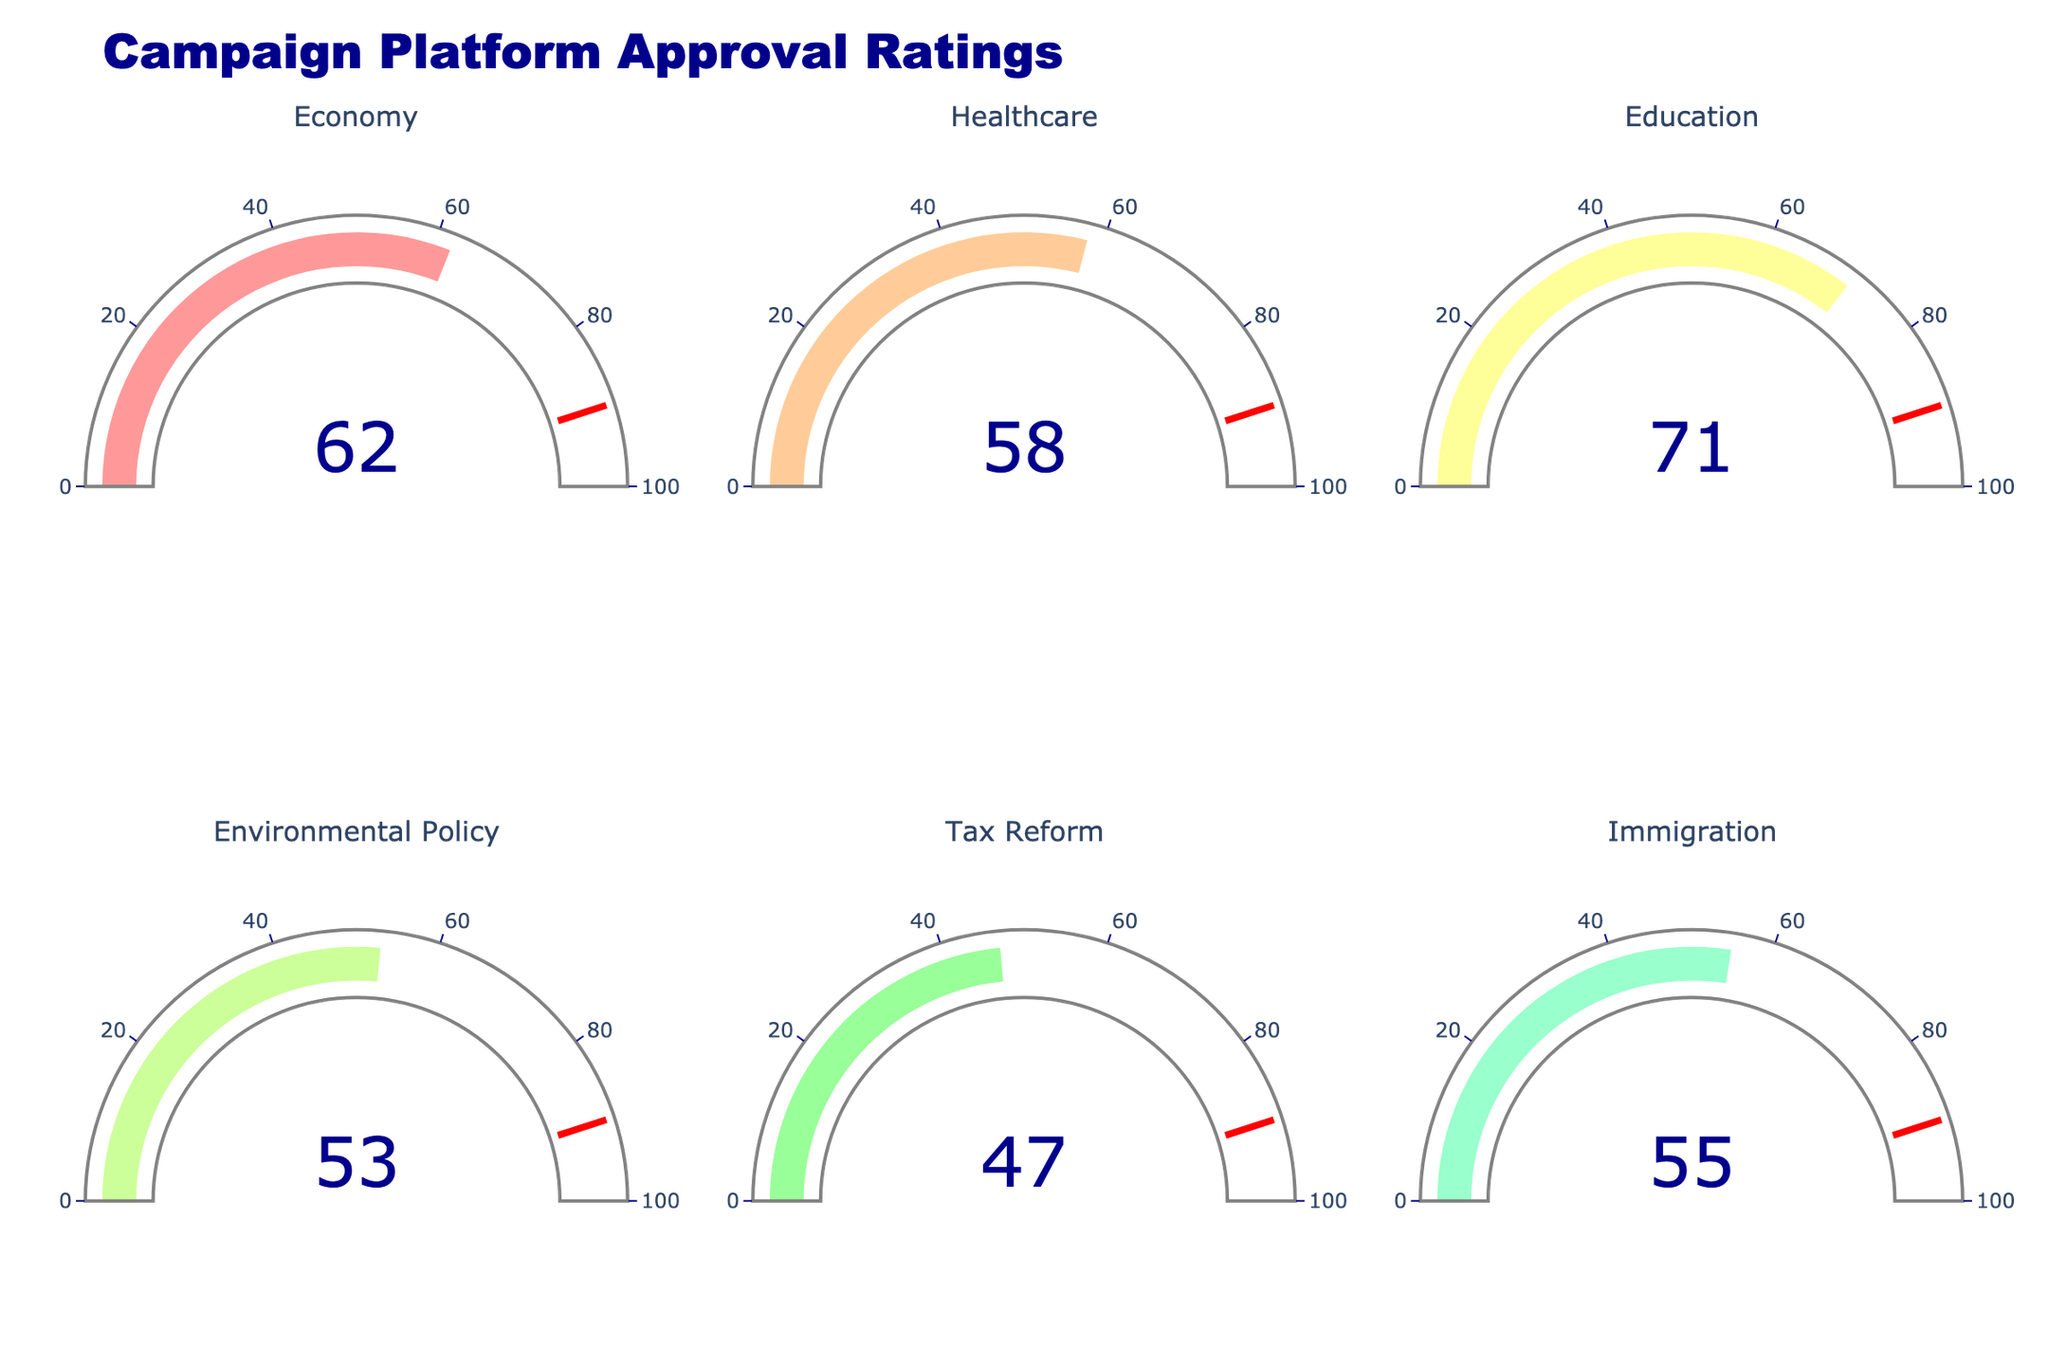What is the title of the figure? The title of the figure is located at the top and reads "Campaign Platform Approval Ratings".
Answer: Campaign Platform Approval Ratings Which platform topic has the highest approval rating? By examining the gauge values for each platform topic, the highest value is on the Education gauge, which shows an approval rating of 71.
Answer: Education What is the approval rating for the Economy platform? The approval rating for the Economy platform is directly shown on its gauge chart, which is the first one on the top left. The value displayed there is 62.
Answer: 62 What is the difference in approval ratings between Healthcare and Environmental Policy? The approval rating for Healthcare is 58 and for Environmental Policy is 53. By subtracting 53 from 58, the difference is 5.
Answer: 5 What is the average approval rating of the listed campaign platforms? Adding the approval ratings: 62 + 58 + 71 + 53 + 47 + 55 = 346. Dividing by the number of platform topics (6), the average is 346/6 ≈ 57.67.
Answer: 57.67 What is the lowest approval rating shown on the figure? By inspecting all the gauges, the lowest approval rating is displayed on the Tax Reform gauge with a value of 47.
Answer: 47 Which platform shows an approval rating below 50? Checking each gauge, the Tax Reform platform shows an approval rating below 50, which is 47.
Answer: Tax Reform How much higher is the approval rating of Education compared to Immigration? The approval rating for Education is 71, and for Immigration, it is 55. Subtracting 55 from 71 gives a difference of 16.
Answer: 16 How many of the platforms have an approval rating above 60? By checking the values, the platforms with an approval rating above 60 are Economy (62), and Education (71). There are 2 platforms that meet this criterion.
Answer: 2 Which platforms have approval ratings that fall between 50 and 60? By examining the gauges, the platforms that fall within the 50-60 range are Healthcare (58) and Environmental Policy (53), and Immigration (55).
Answer: Healthcare, Environmental Policy, Immigration 